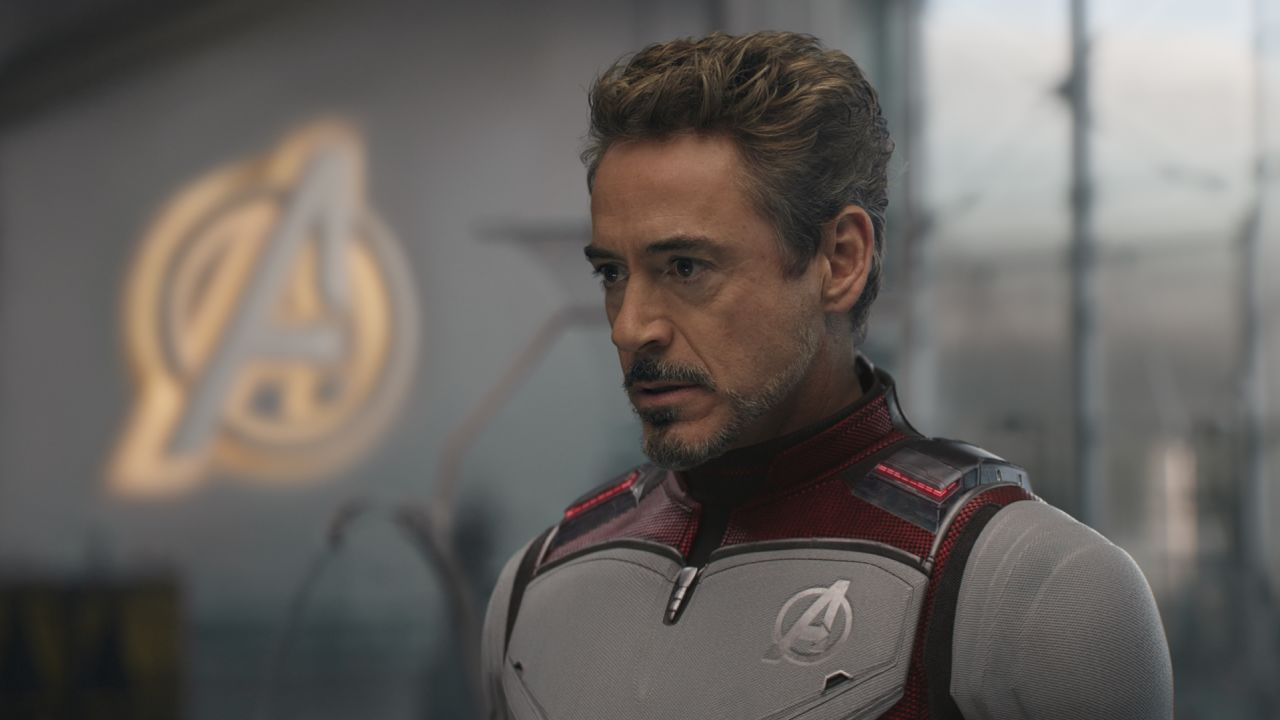What is this photo about'?
 In this image, we see the renowned actor Robert Downey Jr. embodying his iconic character, Tony Stark, from the Marvel Cinematic Universe. He is standing in front of a window that prominently displays the Avengers logo. Dressed in a suit of red and gray, the Avengers logo is also visible on his chest and shoulder, signifying his allegiance to the superhero team. His gaze is directed off to the side, and his expression is serious, perhaps indicative of the weighty responsibilities he bears as a member of the Avengers. 